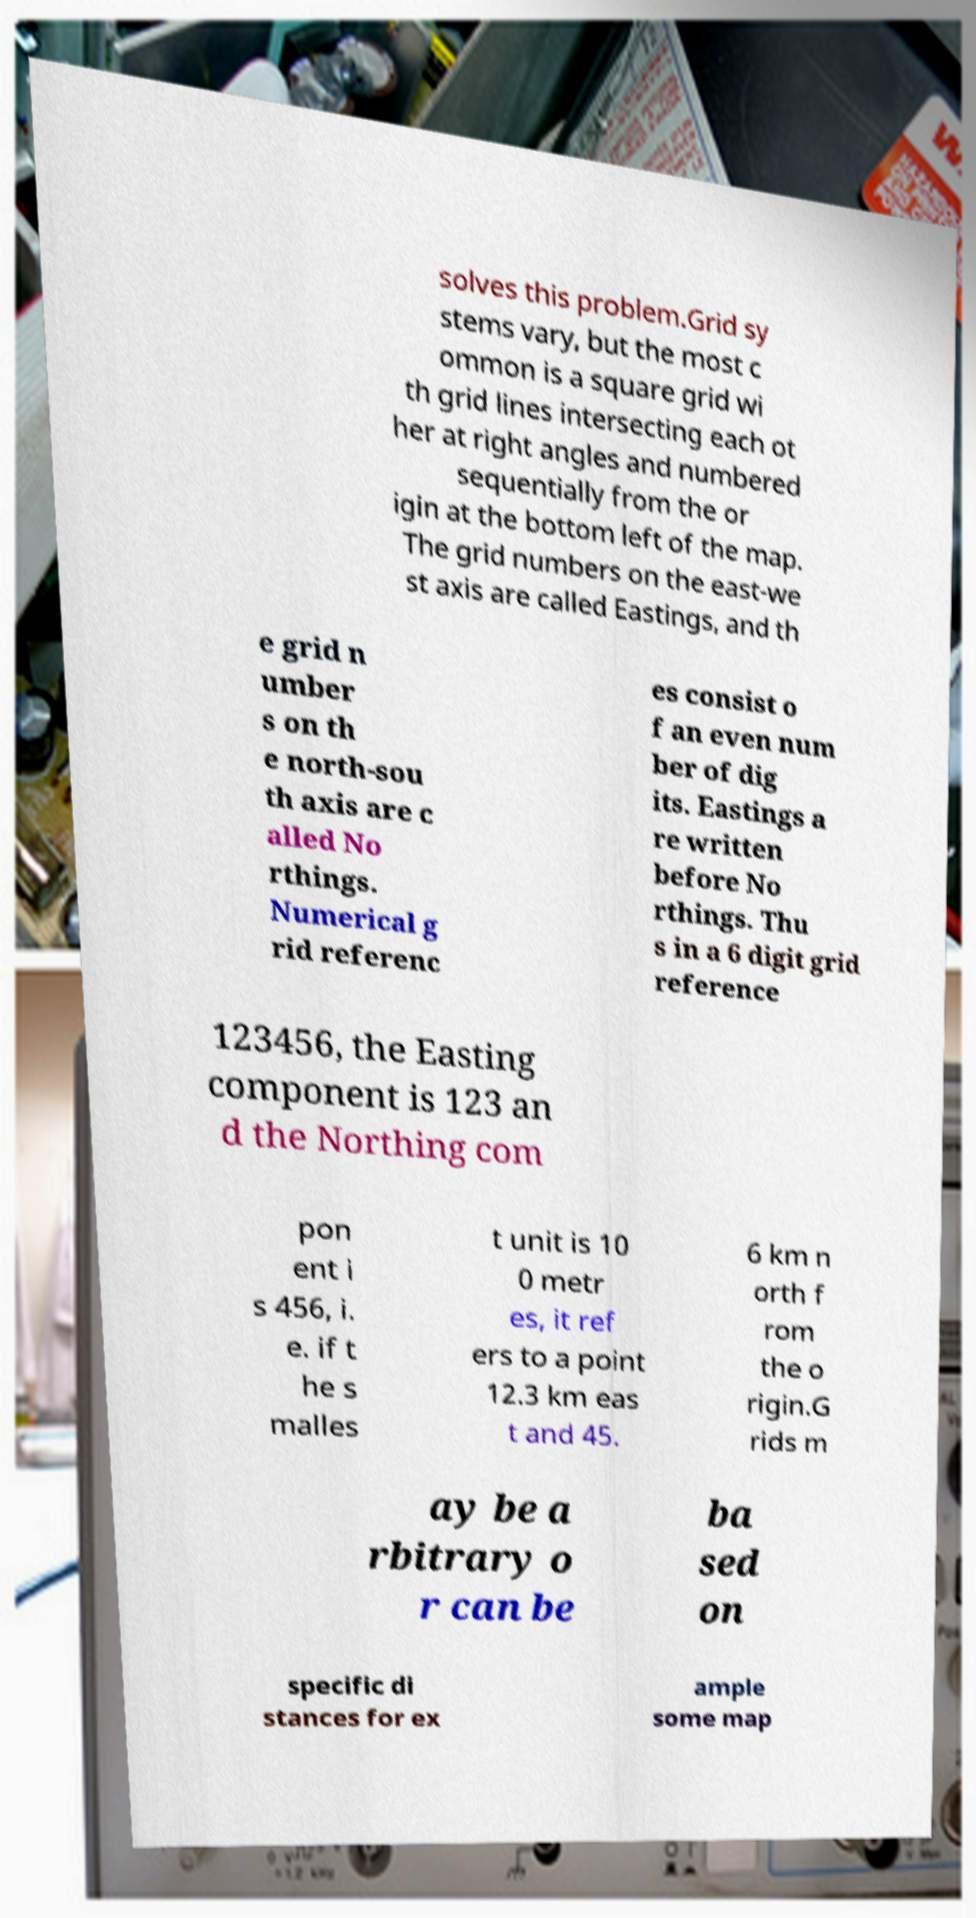Please read and relay the text visible in this image. What does it say? solves this problem.Grid sy stems vary, but the most c ommon is a square grid wi th grid lines intersecting each ot her at right angles and numbered sequentially from the or igin at the bottom left of the map. The grid numbers on the east-we st axis are called Eastings, and th e grid n umber s on th e north-sou th axis are c alled No rthings. Numerical g rid referenc es consist o f an even num ber of dig its. Eastings a re written before No rthings. Thu s in a 6 digit grid reference 123456, the Easting component is 123 an d the Northing com pon ent i s 456, i. e. if t he s malles t unit is 10 0 metr es, it ref ers to a point 12.3 km eas t and 45. 6 km n orth f rom the o rigin.G rids m ay be a rbitrary o r can be ba sed on specific di stances for ex ample some map 